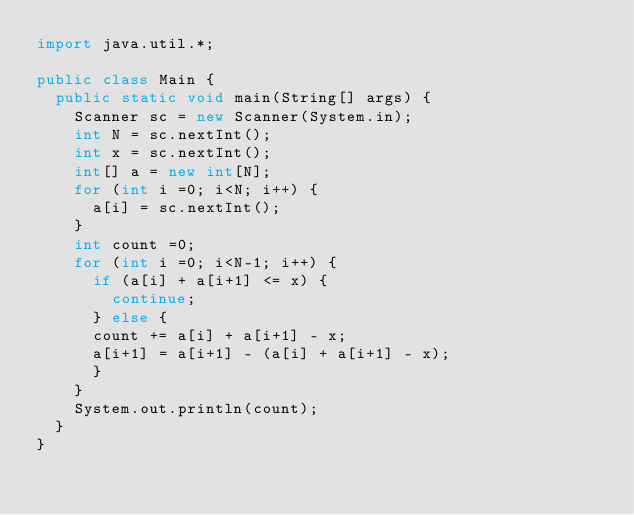<code> <loc_0><loc_0><loc_500><loc_500><_Java_>import java.util.*;

public class Main {
  public static void main(String[] args) {
    Scanner sc = new Scanner(System.in);
    int N = sc.nextInt();
    int x = sc.nextInt();
    int[] a = new int[N];
    for (int i =0; i<N; i++) {
      a[i] = sc.nextInt();
    }
    int count =0;
    for (int i =0; i<N-1; i++) {
      if (a[i] + a[i+1] <= x) {
        continue;
      } else {
      count += a[i] + a[i+1] - x;
      a[i+1] = a[i+1] - (a[i] + a[i+1] - x);
      }
    }
    System.out.println(count);
  }
}</code> 